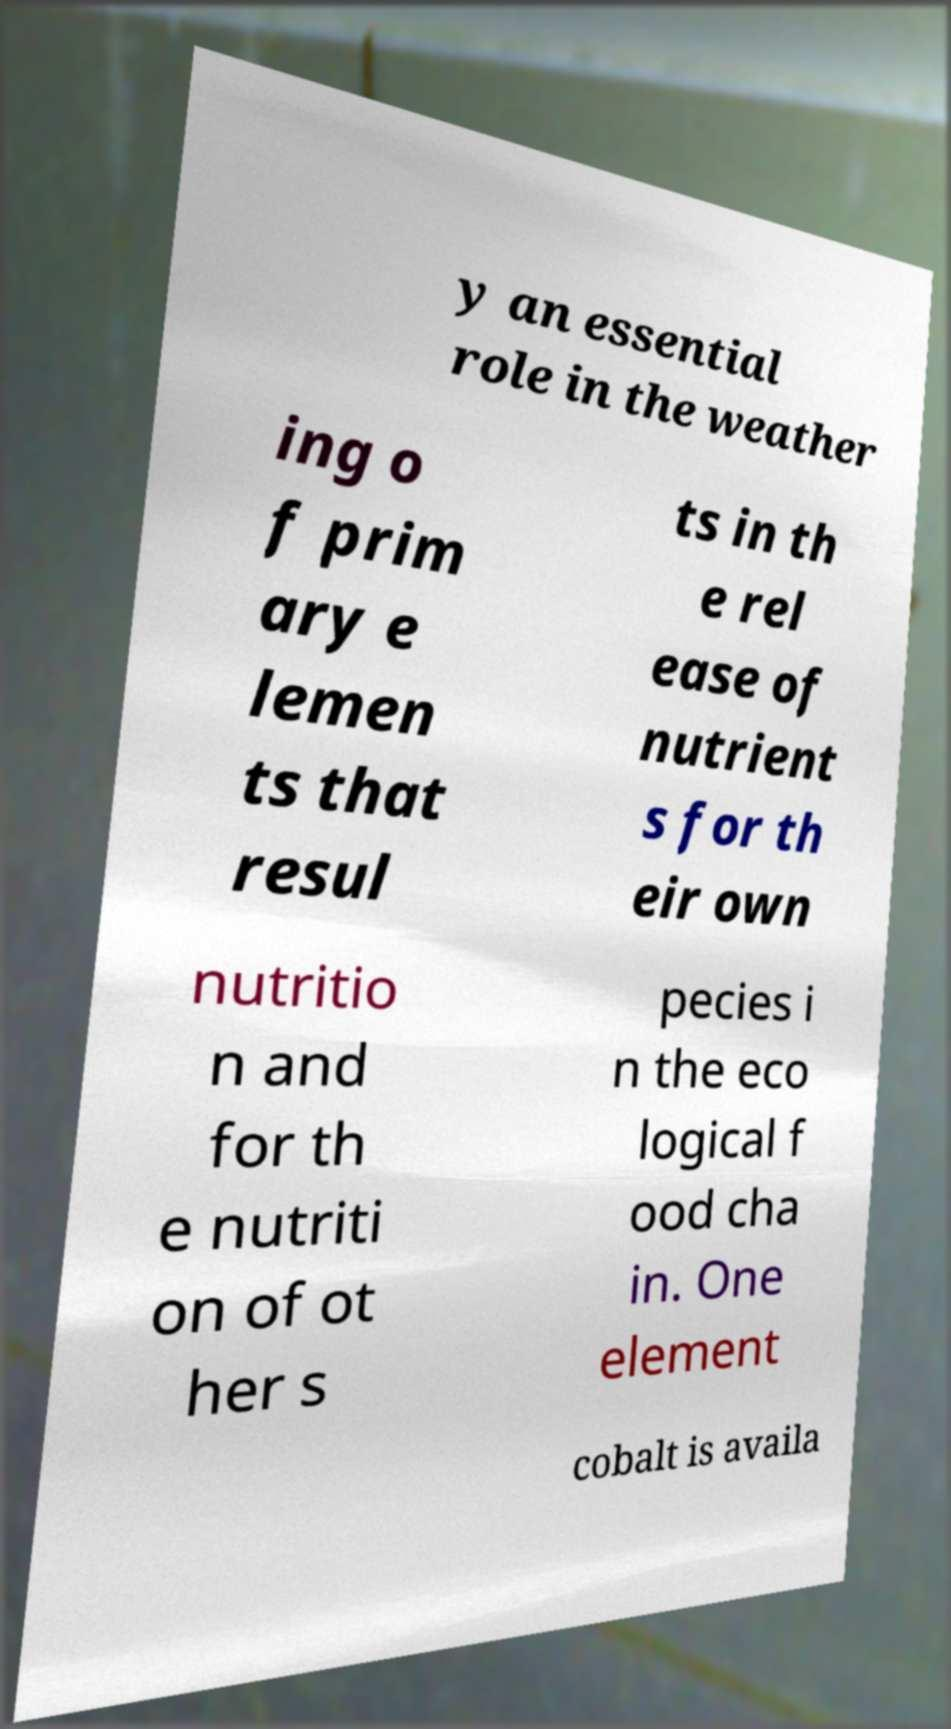Could you extract and type out the text from this image? y an essential role in the weather ing o f prim ary e lemen ts that resul ts in th e rel ease of nutrient s for th eir own nutritio n and for th e nutriti on of ot her s pecies i n the eco logical f ood cha in. One element cobalt is availa 